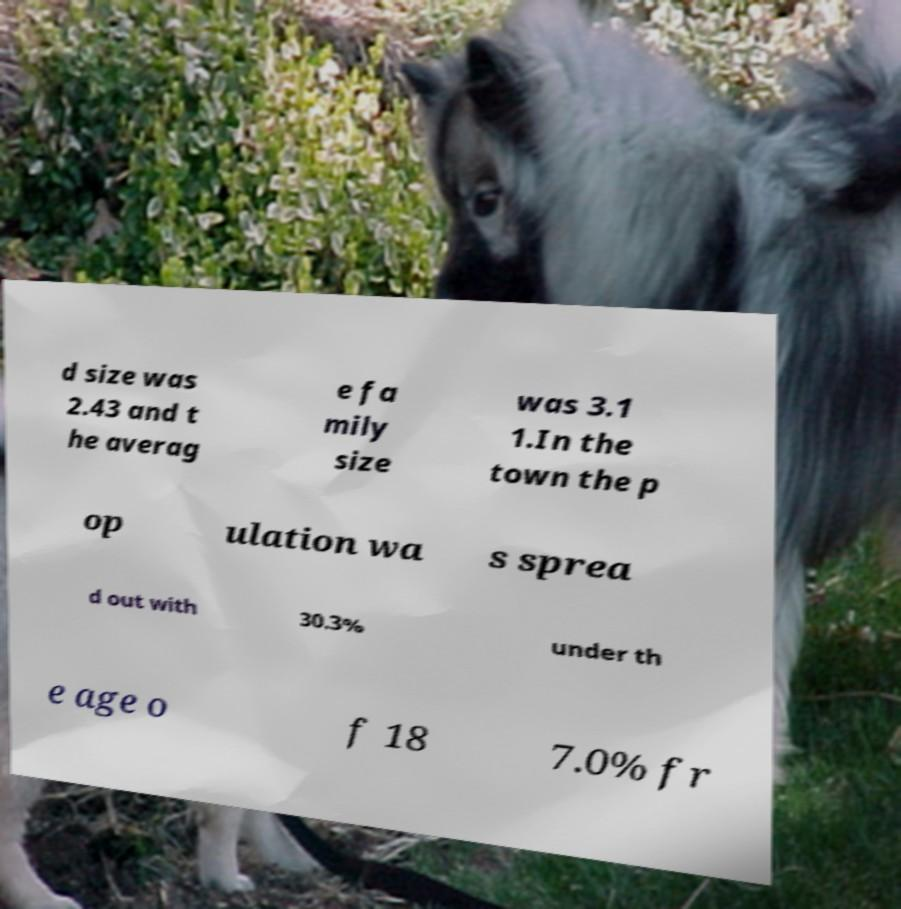There's text embedded in this image that I need extracted. Can you transcribe it verbatim? d size was 2.43 and t he averag e fa mily size was 3.1 1.In the town the p op ulation wa s sprea d out with 30.3% under th e age o f 18 7.0% fr 